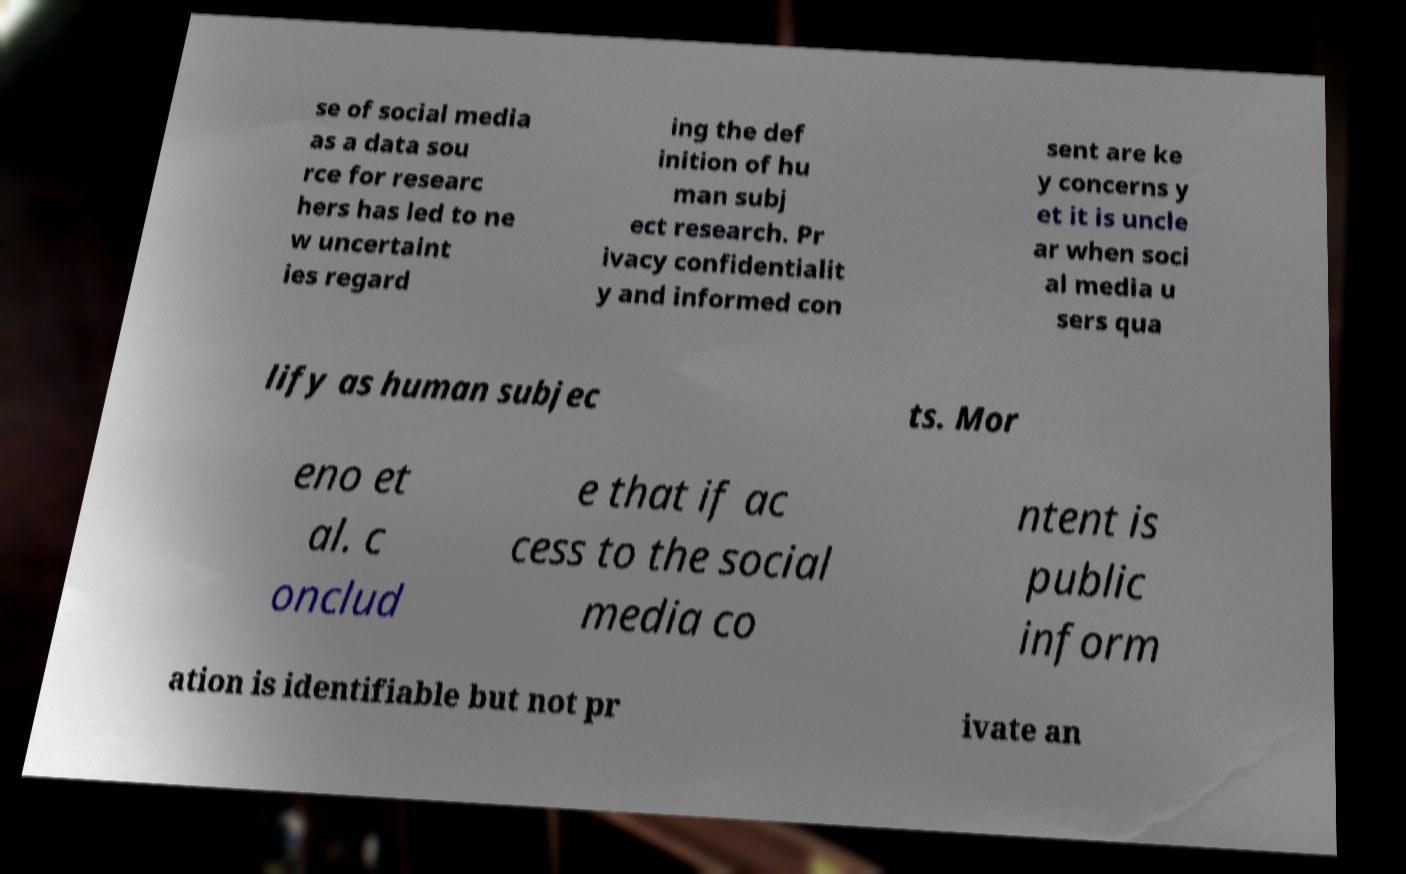For documentation purposes, I need the text within this image transcribed. Could you provide that? se of social media as a data sou rce for researc hers has led to ne w uncertaint ies regard ing the def inition of hu man subj ect research. Pr ivacy confidentialit y and informed con sent are ke y concerns y et it is uncle ar when soci al media u sers qua lify as human subjec ts. Mor eno et al. c onclud e that if ac cess to the social media co ntent is public inform ation is identifiable but not pr ivate an 